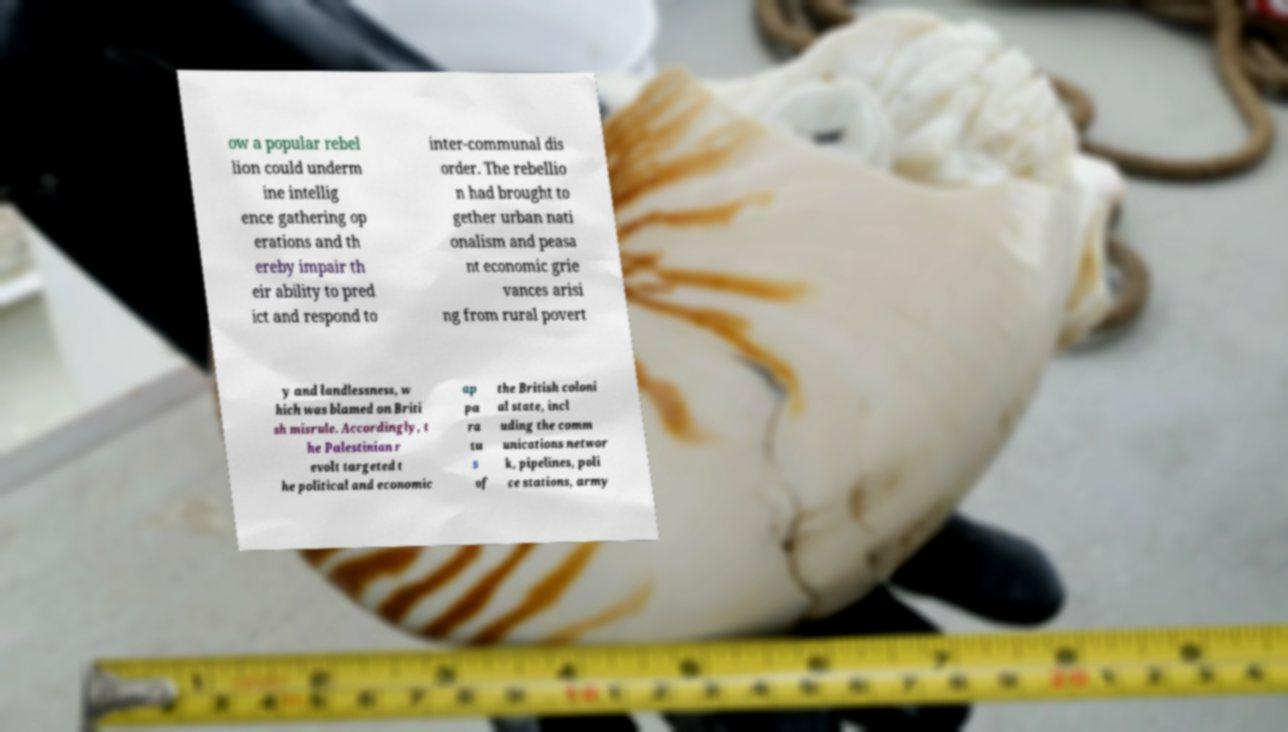Can you accurately transcribe the text from the provided image for me? ow a popular rebel lion could underm ine intellig ence gathering op erations and th ereby impair th eir ability to pred ict and respond to inter-communal dis order. The rebellio n had brought to gether urban nati onalism and peasa nt economic grie vances arisi ng from rural povert y and landlessness, w hich was blamed on Briti sh misrule. Accordingly, t he Palestinian r evolt targeted t he political and economic ap pa ra tu s of the British coloni al state, incl uding the comm unications networ k, pipelines, poli ce stations, army 